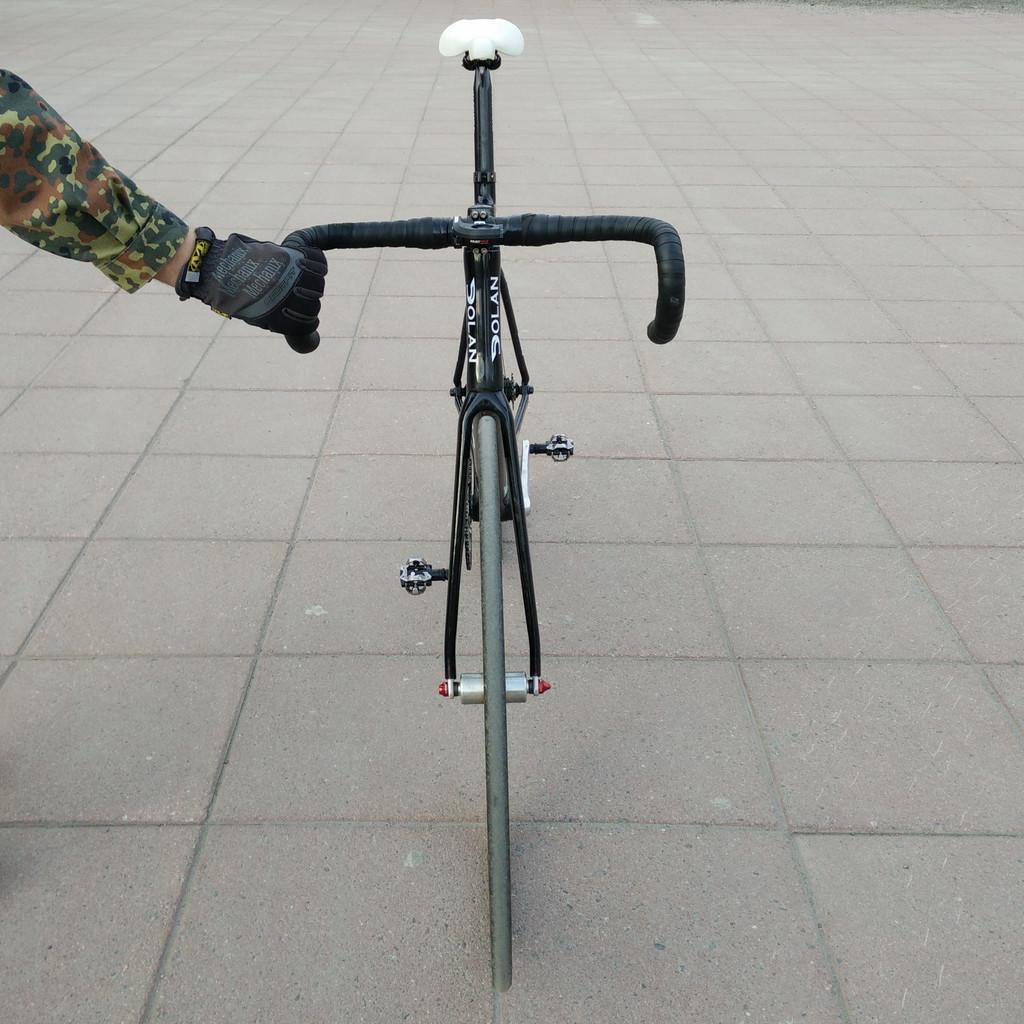How would you summarize this image in a sentence or two? In this picture we can see a person's hand holding the handle of a cycle parked on the ground. We can also see the wheel, pedals and a white seat. 